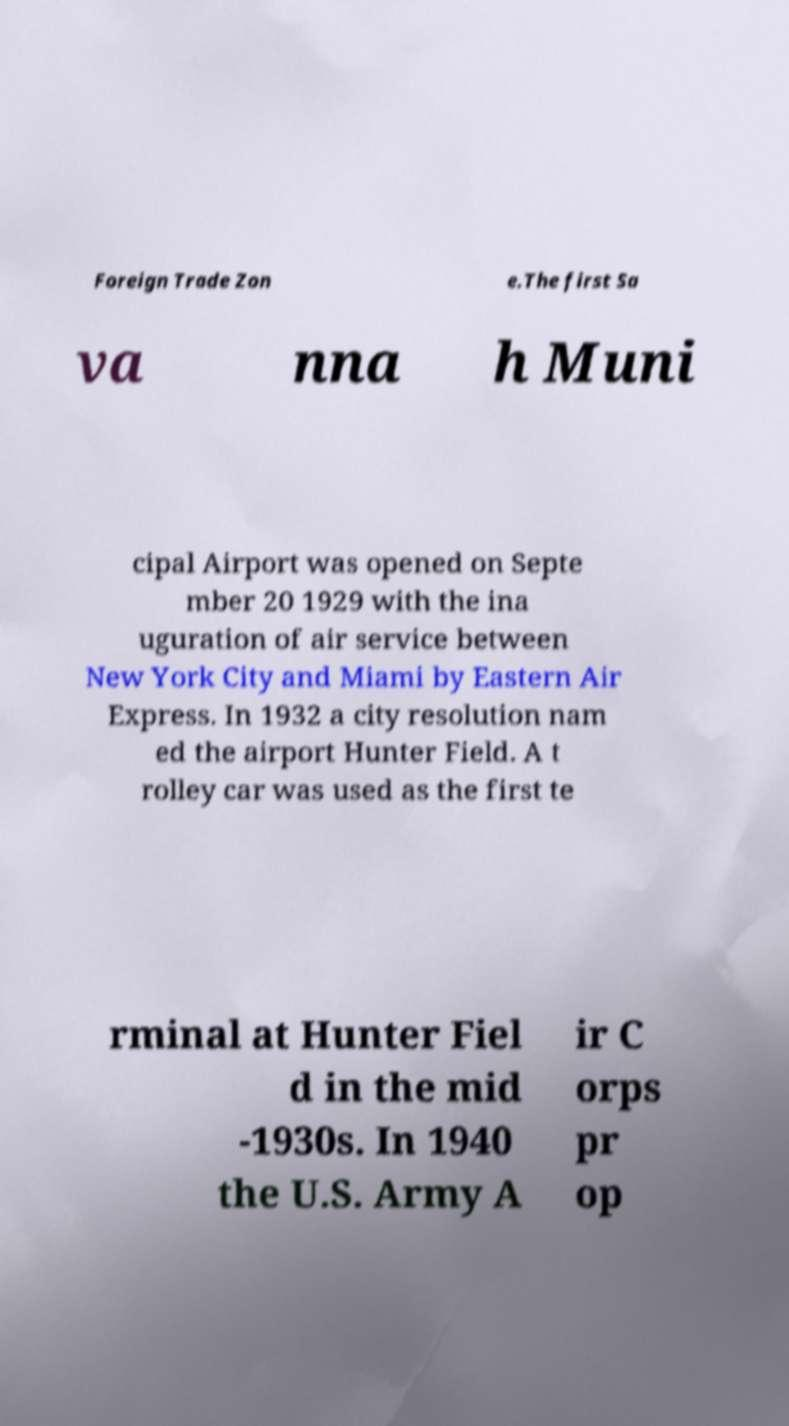Can you accurately transcribe the text from the provided image for me? Foreign Trade Zon e.The first Sa va nna h Muni cipal Airport was opened on Septe mber 20 1929 with the ina uguration of air service between New York City and Miami by Eastern Air Express. In 1932 a city resolution nam ed the airport Hunter Field. A t rolley car was used as the first te rminal at Hunter Fiel d in the mid -1930s. In 1940 the U.S. Army A ir C orps pr op 